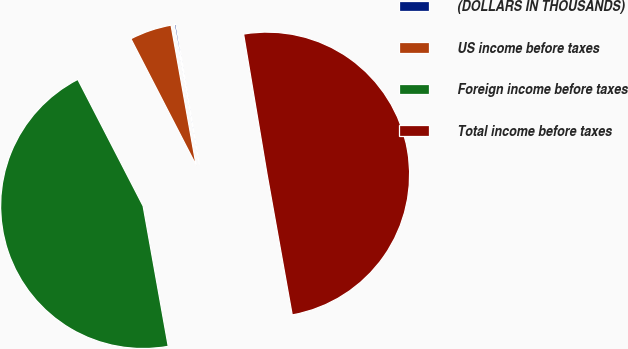Convert chart. <chart><loc_0><loc_0><loc_500><loc_500><pie_chart><fcel>(DOLLARS IN THOUSANDS)<fcel>US income before taxes<fcel>Foreign income before taxes<fcel>Total income before taxes<nl><fcel>0.18%<fcel>4.76%<fcel>45.24%<fcel>49.82%<nl></chart> 